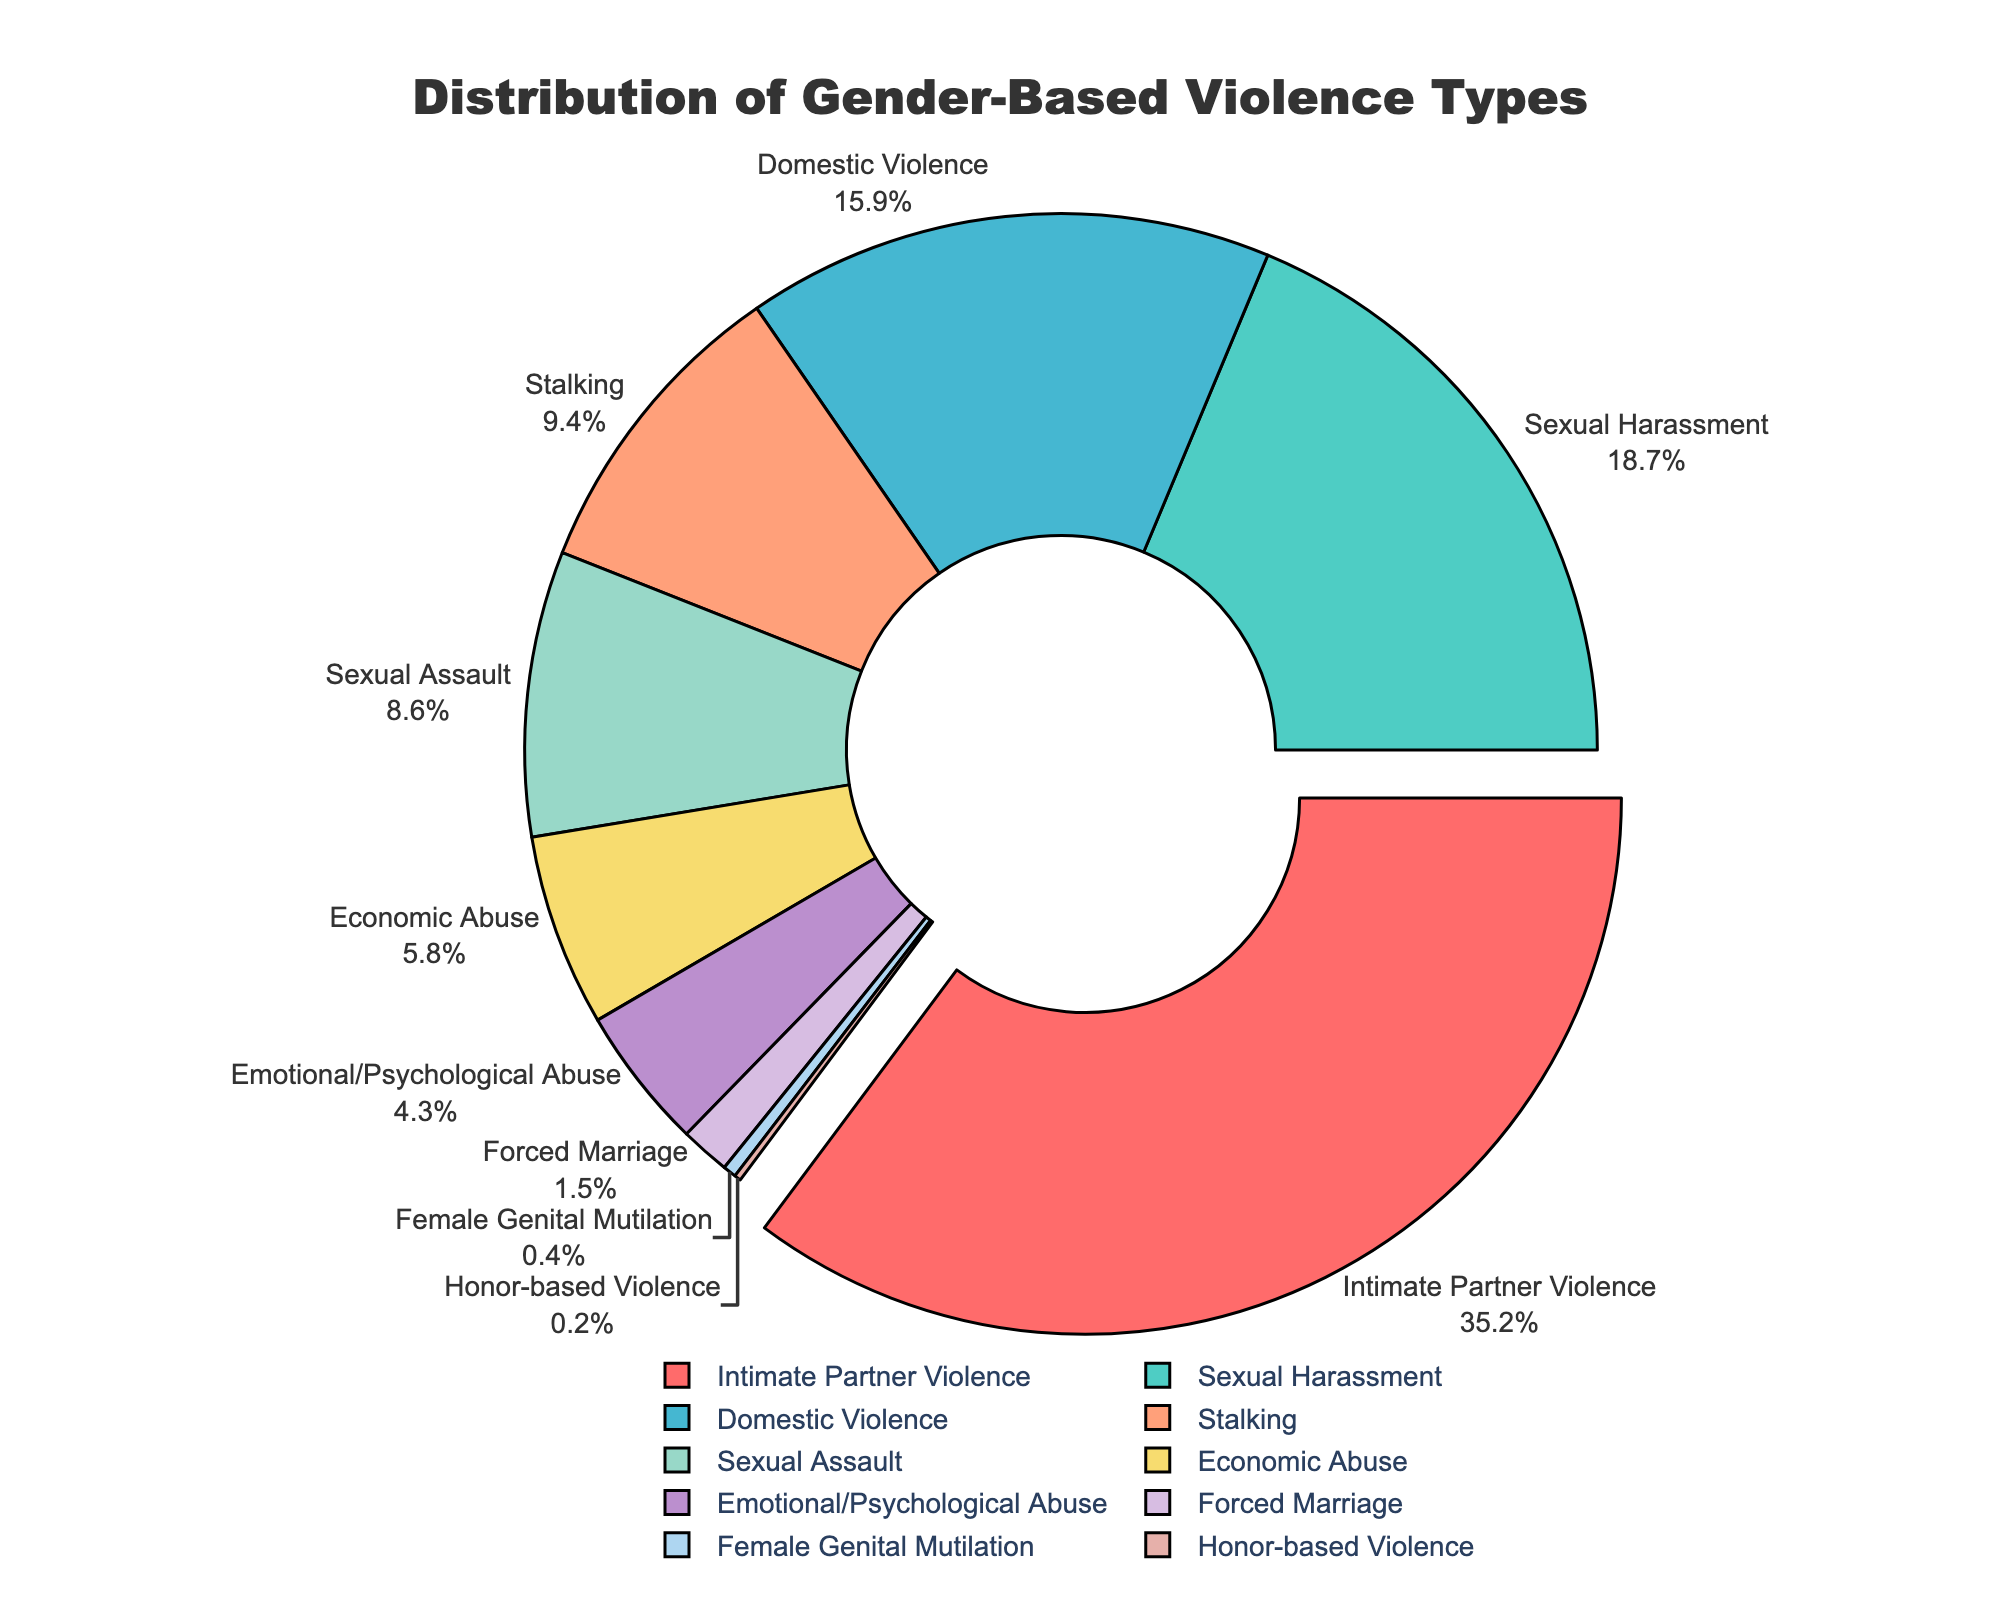What percentage of reported cases belong to Intimate Partner Violence? The figure shows the percentage of reported cases for each type of gender-based violence. By checking the label for Intimate Partner Violence, we can see it is given as 35.2%.
Answer: 35.2% Which type of violence has the smallest percentage of reported cases? According to the labels on the pie chart, Honor-based Violence has the smallest segment, with a reported percentage of 0.2%.
Answer: Honor-based Violence What are the combined percentages of Sexual Harassment and Sexual Assault? To find the combined percentage, sum the reported percentages of Sexual Harassment and Sexual Assault: 18.7% + 8.6% = 27.3%.
Answer: 27.3% Compare the percentage of Domestic Violence to Stalking. Which one is greater and by how much? The figure shows Domestic Violence at 15.9% and Stalking at 9.4%. Subtract the smaller percentage from the larger one: 15.9% - 9.4% = 6.5%. Domestic Violence is greater by 6.5%.
Answer: Domestic Violence, by 6.5% Which segment is visually pulled out from the pie chart? The visual attribute of the pie chart with a segment slightly pulled out indicates Intimate Partner Violence, highlighting its significance.
Answer: Intimate Partner Violence Among the less common types, which one has a higher reported percentage, Forced Marriage or Female Genital Mutilation? The labels show Forced Marriage at 1.5% and Female Genital Mutilation at 0.4%. Forced Marriage has a higher reported percentage.
Answer: Forced Marriage What is the total percentage of reported cases of Economic Abuse and Emotional/Psychological Abuse? Sum the percentages of Economic Abuse (5.8%) and Emotional/Psychological Abuse (4.3%): 5.8% + 4.3% = 10.1%.
Answer: 10.1% Arrange the following types of violence in ascending order of their reported percentages: Sexual Harassment, Stalking, Economic Abuse, and Honor-based Violence. The pie chart shows the percentages as Sexual Harassment (18.7%), Stalking (9.4%), Economic Abuse (5.8%), and Honor-based Violence (0.2%). Arranging them in ascending order: Honor-based Violence (0.2%), Economic Abuse (5.8%), Stalking (9.4%), and Sexual Harassment (18.7%).
Answer: Honor-based Violence, Economic Abuse, Stalking, Sexual Harassment What type of violence, represented by a light green color on the pie chart, involves a 4.3% reported percentage? By checking the color legend, the type involving 4.3% and marked with a light green color is Emotional/Psychological Abuse.
Answer: Emotional/Psychological Abuse If the categories of Domestic Violence and Emotional/Psychological Abuse are combined, what percentage of the total cases do they represent? Combine the reported percentages of Domestic Violence (15.9%) and Emotional/Psychological Abuse (4.3%): 15.9% + 4.3% = 20.2%.
Answer: 20.2% 